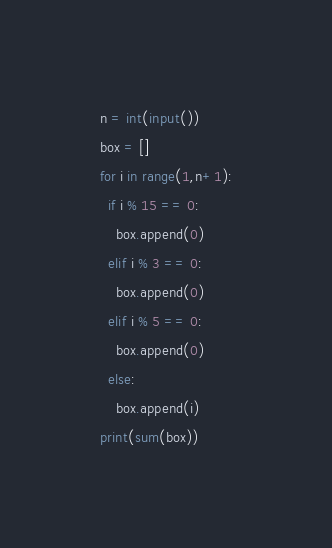<code> <loc_0><loc_0><loc_500><loc_500><_Python_>n = int(input())
box = []
for i in range(1,n+1):
  if i % 15 == 0:
    box.append(0)
  elif i % 3 == 0:
    box.append(0)
  elif i % 5 == 0:
    box.append(0)
  else:
    box.append(i)
print(sum(box))</code> 